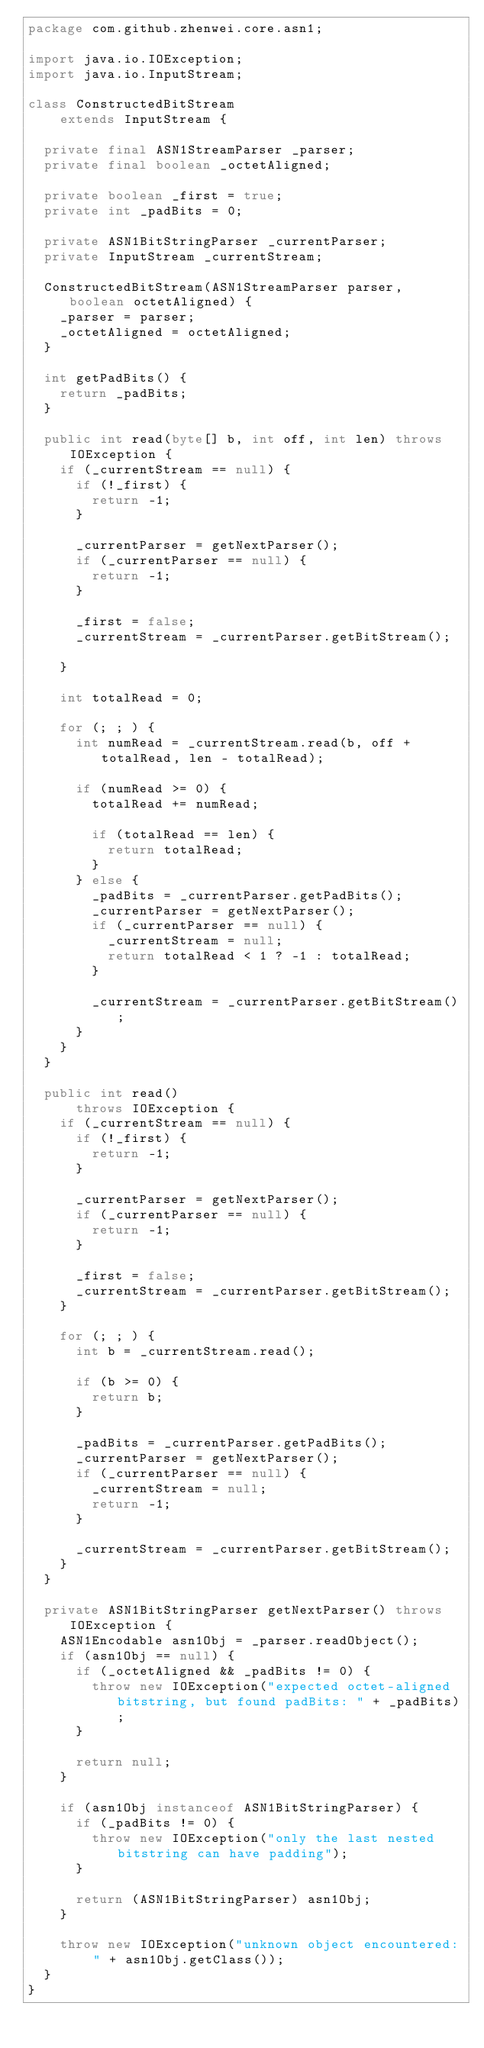Convert code to text. <code><loc_0><loc_0><loc_500><loc_500><_Java_>package com.github.zhenwei.core.asn1;

import java.io.IOException;
import java.io.InputStream;

class ConstructedBitStream
    extends InputStream {

  private final ASN1StreamParser _parser;
  private final boolean _octetAligned;

  private boolean _first = true;
  private int _padBits = 0;

  private ASN1BitStringParser _currentParser;
  private InputStream _currentStream;

  ConstructedBitStream(ASN1StreamParser parser, boolean octetAligned) {
    _parser = parser;
    _octetAligned = octetAligned;
  }

  int getPadBits() {
    return _padBits;
  }

  public int read(byte[] b, int off, int len) throws IOException {
    if (_currentStream == null) {
      if (!_first) {
        return -1;
      }

      _currentParser = getNextParser();
      if (_currentParser == null) {
        return -1;
      }

      _first = false;
      _currentStream = _currentParser.getBitStream();

    }

    int totalRead = 0;

    for (; ; ) {
      int numRead = _currentStream.read(b, off + totalRead, len - totalRead);

      if (numRead >= 0) {
        totalRead += numRead;

        if (totalRead == len) {
          return totalRead;
        }
      } else {
        _padBits = _currentParser.getPadBits();
        _currentParser = getNextParser();
        if (_currentParser == null) {
          _currentStream = null;
          return totalRead < 1 ? -1 : totalRead;
        }

        _currentStream = _currentParser.getBitStream();
      }
    }
  }

  public int read()
      throws IOException {
    if (_currentStream == null) {
      if (!_first) {
        return -1;
      }

      _currentParser = getNextParser();
      if (_currentParser == null) {
        return -1;
      }

      _first = false;
      _currentStream = _currentParser.getBitStream();
    }

    for (; ; ) {
      int b = _currentStream.read();

      if (b >= 0) {
        return b;
      }

      _padBits = _currentParser.getPadBits();
      _currentParser = getNextParser();
      if (_currentParser == null) {
        _currentStream = null;
        return -1;
      }

      _currentStream = _currentParser.getBitStream();
    }
  }

  private ASN1BitStringParser getNextParser() throws IOException {
    ASN1Encodable asn1Obj = _parser.readObject();
    if (asn1Obj == null) {
      if (_octetAligned && _padBits != 0) {
        throw new IOException("expected octet-aligned bitstring, but found padBits: " + _padBits);
      }

      return null;
    }

    if (asn1Obj instanceof ASN1BitStringParser) {
      if (_padBits != 0) {
        throw new IOException("only the last nested bitstring can have padding");
      }

      return (ASN1BitStringParser) asn1Obj;
    }

    throw new IOException("unknown object encountered: " + asn1Obj.getClass());
  }
}</code> 